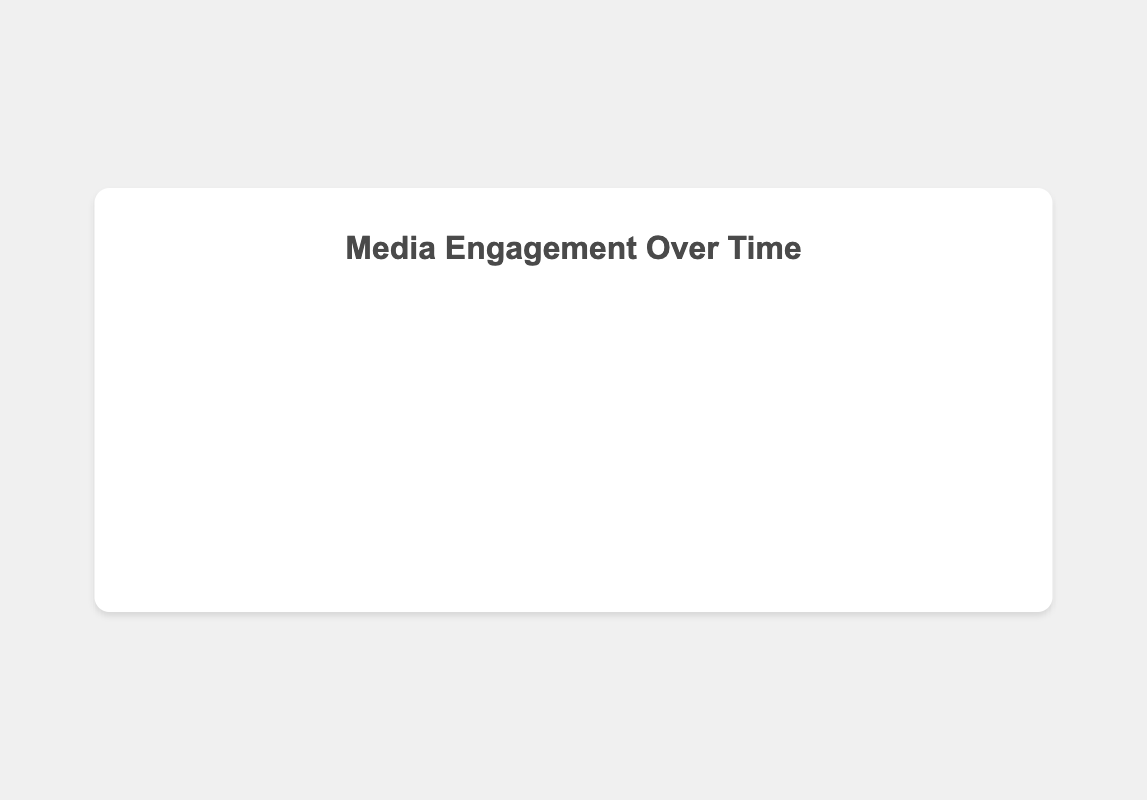Which platform has the highest engagement in October 2023? By visually inspecting the lines on the graph for October 2023, we see that TikTok's line is the highest.
Answer: TikTok How much did Instagram's engagement increase from January to October 2023? Starting engagement in January for Instagram is 4500, and in October, it is 6900. The increase is 6900 - 4500 = 2400.
Answer: 2400 Which platform had a decrease in engagement between July and August 2023? Checking the plot visually for changes between July and August 2023, both Instagram and Facebook show a decline in their respective lines.
Answer: Instagram and Facebook What is the average engagement for Facebook from January to October 2023? The engagements for Facebook are 5000, 5200, 5400, 5600, 5800, 5900, 6000, 5800, 5700, and 6000. The sum is 56400, and there are 10 data points, so the average is 56400 / 10 = 5640.
Answer: 5640 In which month did Twitter reach its lowest engagement, and what was the value? By looking at the plot, Twitter's lowest point is in February 2023 with an engagement of 3000.
Answer: February 2023, 3000 Which two platforms tend to have a similar engagement pattern over the months? By comparing the shapes of the engagement lines, Instagram and Facebook have similar increasing trends and even both show a drop in August 2023.
Answer: Instagram and Facebook Between which months is the biggest increase in engagement for TikTok? By visually examining the steepest increase in TikTok's line, it occurs from April to May 2023 from 7700 to 8000, a difference of 300 engagements.
Answer: April to May 2023 What is the total engagement for all platforms in May 2023? Summing the engagements: Instagram (5600) + Twitter (3500) + Facebook (5800) + TikTok (8000) = 22900.
Answer: 22900 How many times did Instagram's engagement exceed Twitter's engagement from January to October 2023? By counting the months where Instagram's line is higher than Twitter's, there are 10 instances, from January to October.
Answer: 10 Which platform showed the most fluctuation in engagement throughout 2023? Examining the variaions in the lines, Twitter's path appears more fluctuating, especially noticeable periods of rise and fall compared to others.
Answer: Twitter 